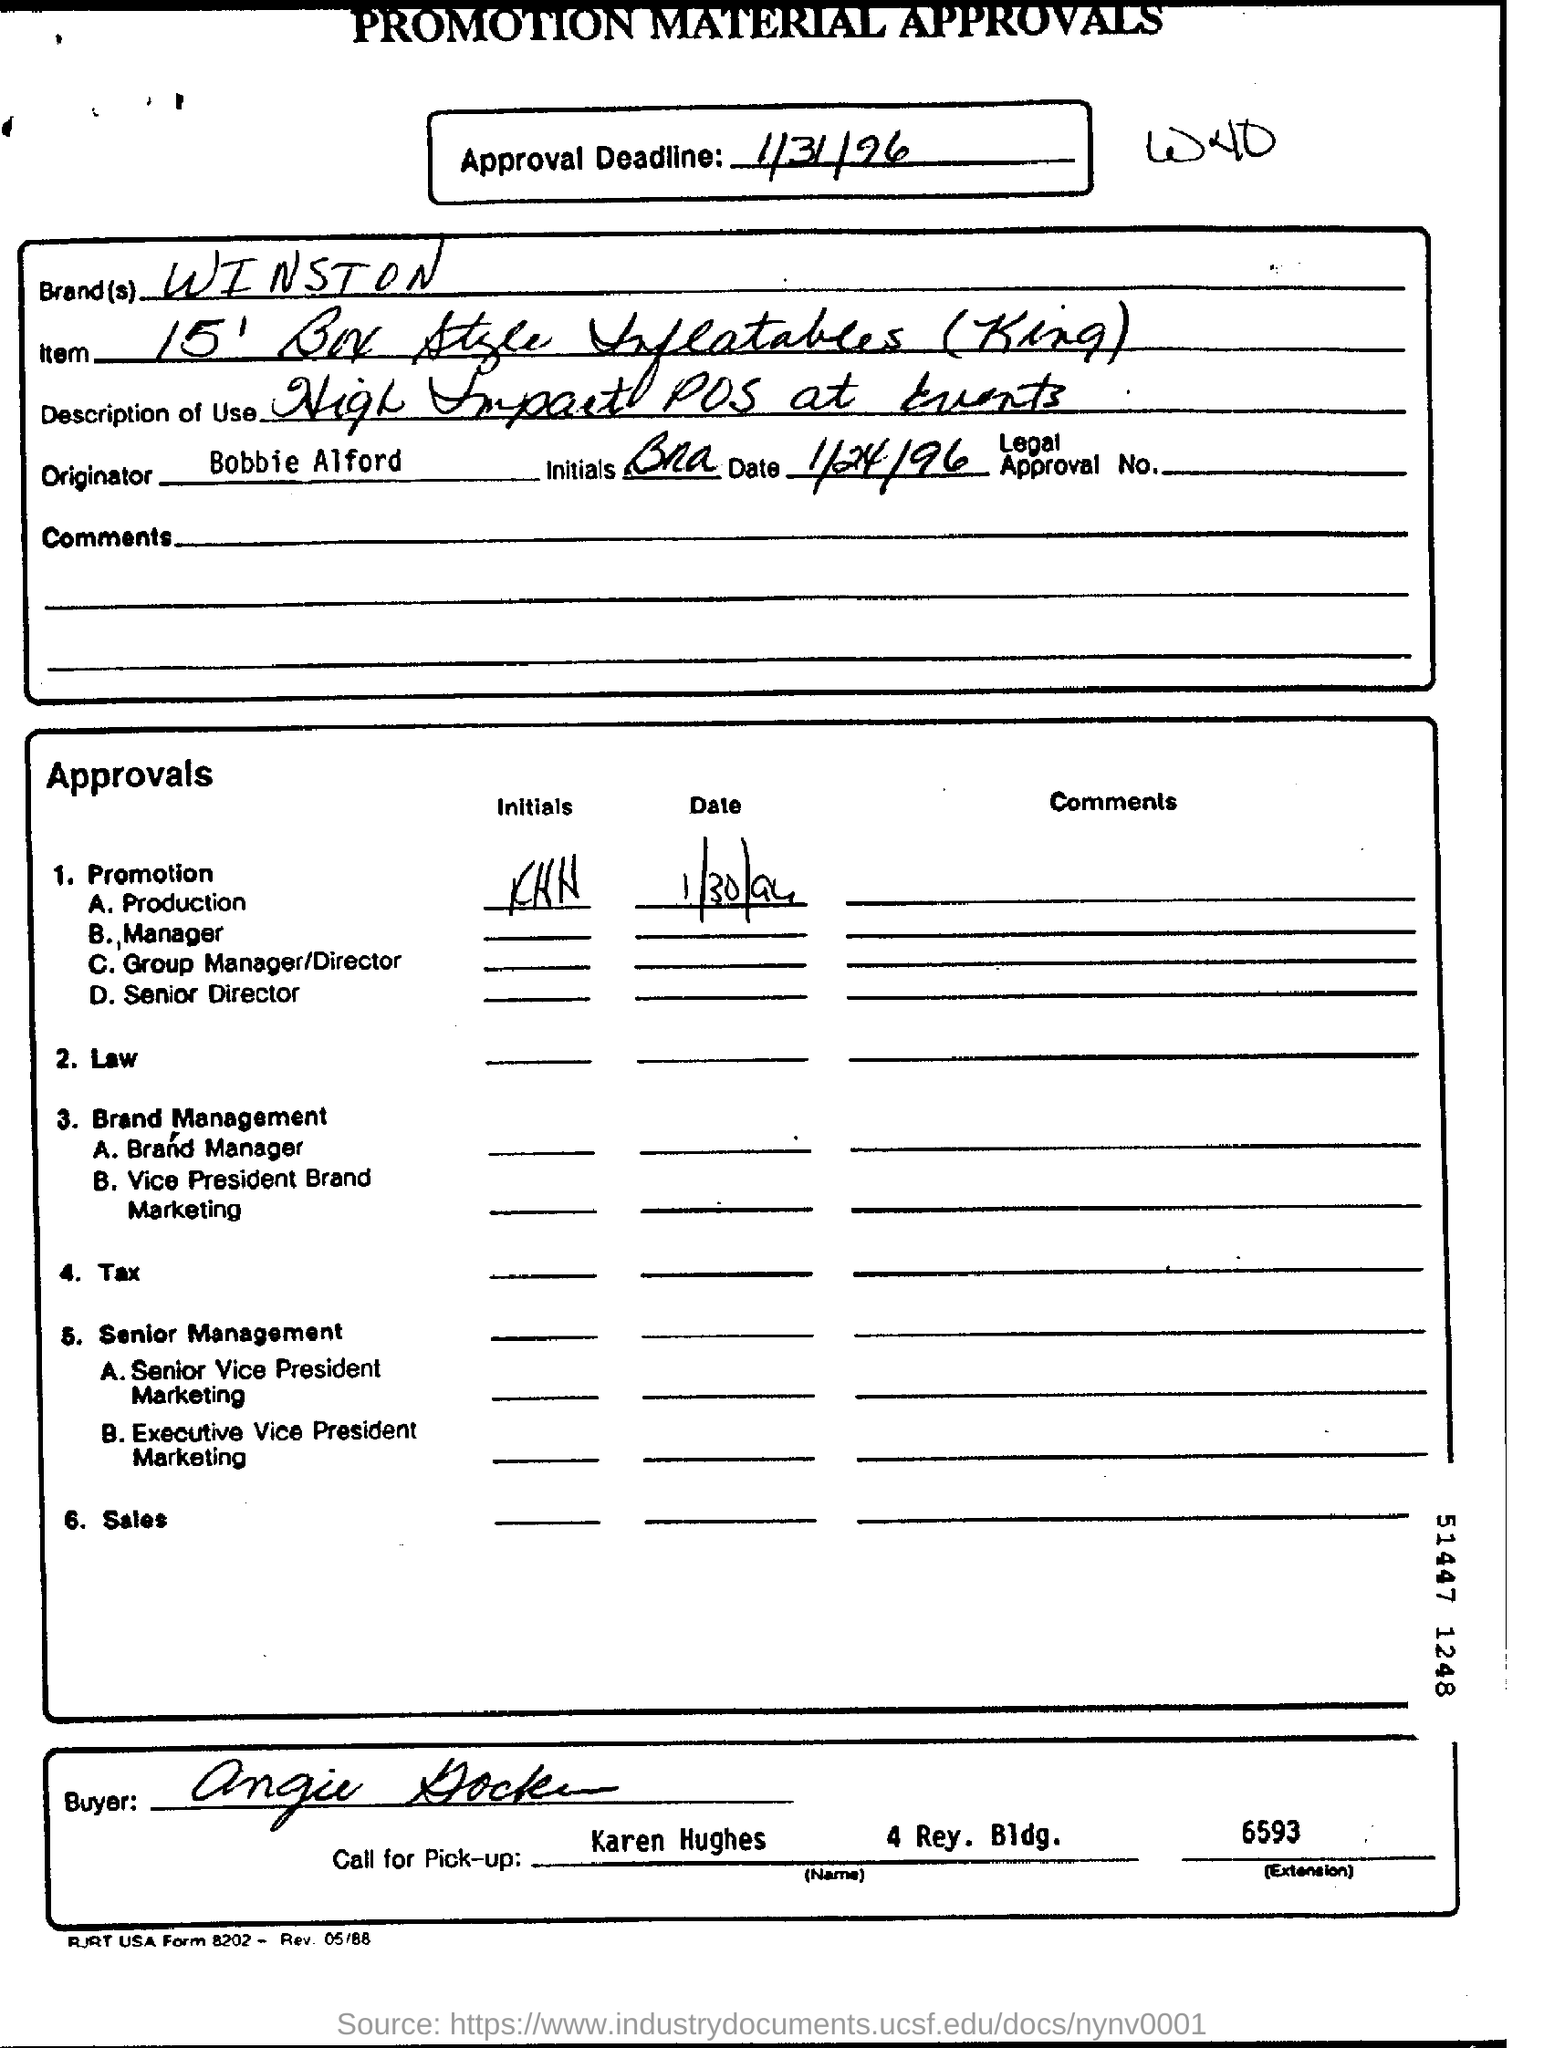What is the Brand?
Your answer should be very brief. Winston. Who is the Originator?
Provide a succinct answer. Bobbie Alford. What is the "Name" for "Call for Pick-up"?
Keep it short and to the point. Karen Hughes. What is the Approval Deadline?
Your answer should be compact. 1/31/96. 